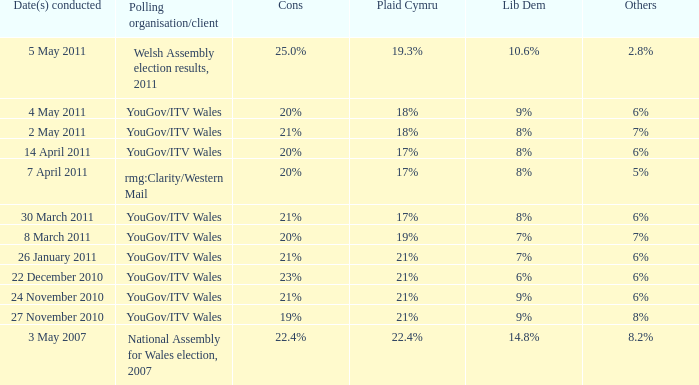Tell me the dates conducted for plaid cymru of 19% 8 March 2011. 